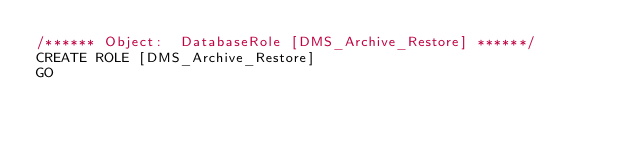<code> <loc_0><loc_0><loc_500><loc_500><_SQL_>/****** Object:  DatabaseRole [DMS_Archive_Restore] ******/
CREATE ROLE [DMS_Archive_Restore]
GO
</code> 